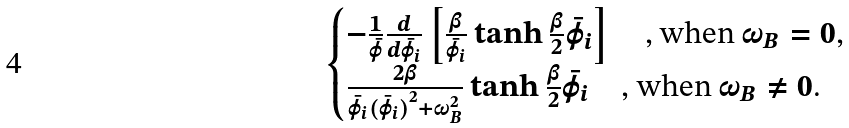<formula> <loc_0><loc_0><loc_500><loc_500>\begin{cases} - \frac { 1 } { \bar { \varphi } } \frac { d } { d \bar { \varphi } _ { i } } \left [ \frac { \beta } { \bar { \varphi } _ { i } } \tanh \frac { \beta } { 2 } \bar { \varphi } _ { i } \right ] \quad \text {, when $\omega_{B} = 0$,} \\ \frac { 2 \beta } { \bar { \varphi } _ { i } ( { \bar { \varphi } _ { i } ) } ^ { 2 } + \omega _ { B } ^ { 2 } } \tanh \frac { \beta } { 2 } \bar { \varphi } _ { i } \quad \text {, when $\omega_{B} \not= 0$.} \end{cases}</formula> 